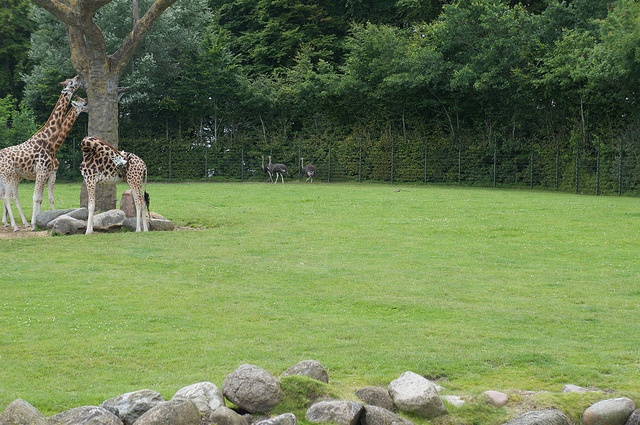Describe the objects in this image and their specific colors. I can see giraffe in darkgreen, darkgray, gray, and lightgray tones, giraffe in darkgreen, darkgray, gray, and black tones, giraffe in darkgreen, darkgray, gray, and olive tones, bird in darkgreen, gray, black, and darkgray tones, and bird in darkgreen, gray, black, and darkgray tones in this image. 